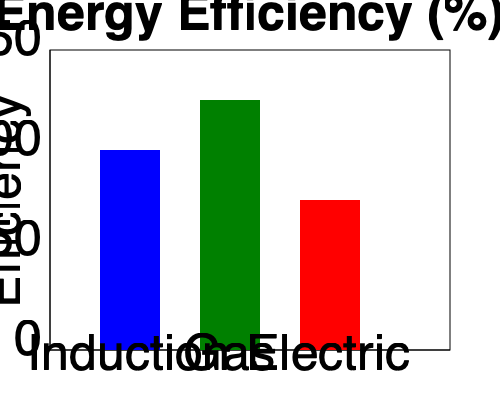A food truck owner is comparing the energy efficiency of different cooking appliances. The bar graph shows the energy efficiency percentages for induction, gas, and electric cooktops. If the food truck owner wants to maximize energy efficiency while cooking 100 meals per day, how many more meals can be prepared using the most efficient cooktop compared to the least efficient one, assuming all other factors remain constant? To solve this problem, we need to follow these steps:

1. Identify the efficiency percentages from the graph:
   Induction: 100%
   Gas: 125%
   Electric: 75%

2. Determine the most and least efficient cooktops:
   Most efficient: Gas (125%)
   Least efficient: Electric (75%)

3. Calculate the difference in efficiency:
   $125\% - 75\% = 50\%$

4. Set up a proportion to find the number of additional meals:
   Let $x$ be the number of additional meals.
   
   $\frac{100 \text{ meals}}{75\%} = \frac{100 \text{ meals} + x}{125\%}$

5. Solve the proportion:
   $\frac{100}{0.75} = \frac{100 + x}{1.25}$
   $133.33 = 80 + 0.8x$
   $53.33 = 0.8x$
   $x = 66.67$

6. Round to the nearest whole number:
   $x \approx 67$ meals

Therefore, using the most efficient cooktop (gas) compared to the least efficient one (electric), the food truck owner can prepare approximately 67 more meals per day, assuming all other factors remain constant.
Answer: 67 meals 